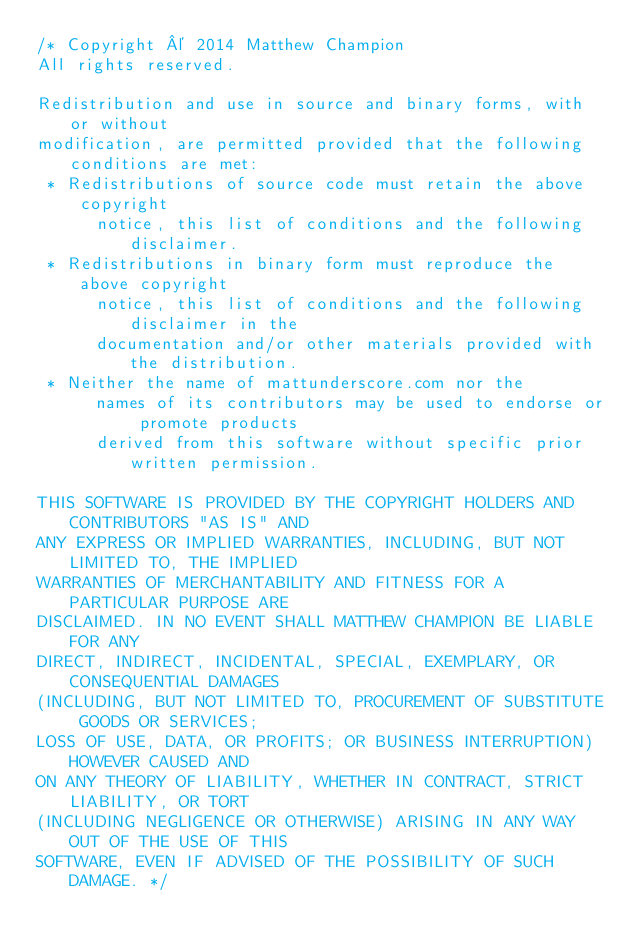Convert code to text. <code><loc_0><loc_0><loc_500><loc_500><_Java_>/* Copyright © 2014 Matthew Champion
All rights reserved.

Redistribution and use in source and binary forms, with or without
modification, are permitted provided that the following conditions are met:
 * Redistributions of source code must retain the above copyright
      notice, this list of conditions and the following disclaimer.
 * Redistributions in binary form must reproduce the above copyright
      notice, this list of conditions and the following disclaimer in the
      documentation and/or other materials provided with the distribution.
 * Neither the name of mattunderscore.com nor the
      names of its contributors may be used to endorse or promote products
      derived from this software without specific prior written permission.

THIS SOFTWARE IS PROVIDED BY THE COPYRIGHT HOLDERS AND CONTRIBUTORS "AS IS" AND
ANY EXPRESS OR IMPLIED WARRANTIES, INCLUDING, BUT NOT LIMITED TO, THE IMPLIED
WARRANTIES OF MERCHANTABILITY AND FITNESS FOR A PARTICULAR PURPOSE ARE
DISCLAIMED. IN NO EVENT SHALL MATTHEW CHAMPION BE LIABLE FOR ANY
DIRECT, INDIRECT, INCIDENTAL, SPECIAL, EXEMPLARY, OR CONSEQUENTIAL DAMAGES
(INCLUDING, BUT NOT LIMITED TO, PROCUREMENT OF SUBSTITUTE GOODS OR SERVICES;
LOSS OF USE, DATA, OR PROFITS; OR BUSINESS INTERRUPTION) HOWEVER CAUSED AND
ON ANY THEORY OF LIABILITY, WHETHER IN CONTRACT, STRICT LIABILITY, OR TORT
(INCLUDING NEGLIGENCE OR OTHERWISE) ARISING IN ANY WAY OUT OF THE USE OF THIS
SOFTWARE, EVEN IF ADVISED OF THE POSSIBILITY OF SUCH DAMAGE. */
</code> 